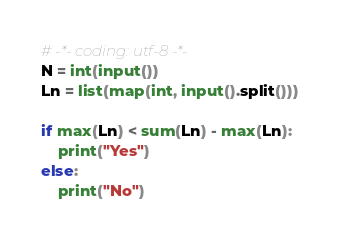<code> <loc_0><loc_0><loc_500><loc_500><_Python_># -*- coding: utf-8 -*-
N = int(input())
Ln = list(map(int, input().split()))

if max(Ln) < sum(Ln) - max(Ln):
    print("Yes")
else:
    print("No")
</code> 